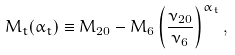<formula> <loc_0><loc_0><loc_500><loc_500>M _ { t } ( \alpha _ { t } ) \equiv M _ { 2 0 } - M _ { 6 } \left ( \frac { \nu _ { 2 0 } } { \nu _ { 6 } } \right ) ^ { \alpha _ { t } } ,</formula> 